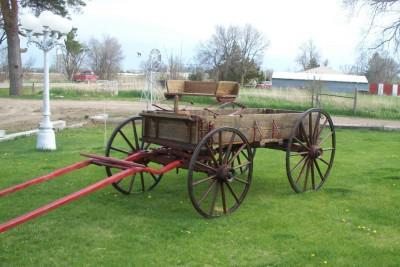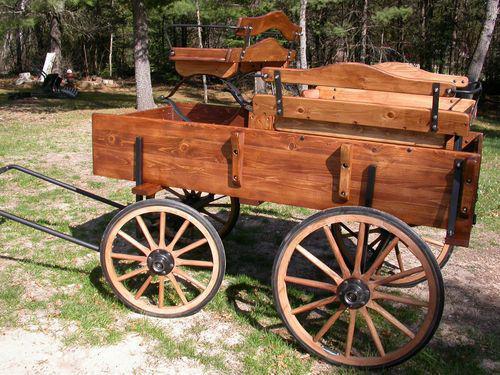The first image is the image on the left, the second image is the image on the right. Given the left and right images, does the statement "An image shows a wooden two-wheeled cart with 'handles' tilted to the ground." hold true? Answer yes or no. No. The first image is the image on the left, the second image is the image on the right. For the images shown, is this caption "At least one of the carts is rectagular and made of wood." true? Answer yes or no. Yes. 